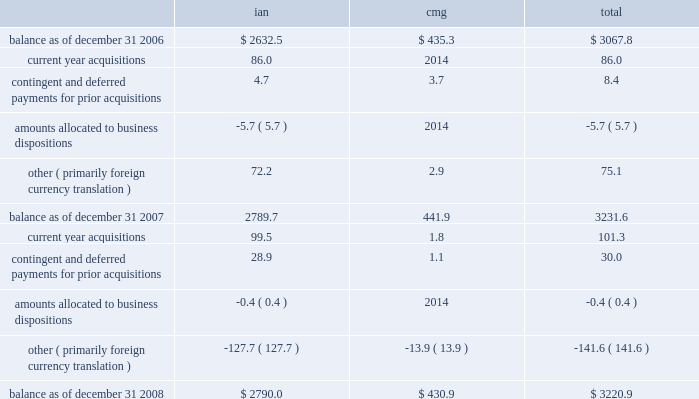Notes to consolidated financial statements 2014 ( continued ) ( amounts in millions , except per share amounts ) litigation settlement 2014 during may 2008 , the sec concluded its investigation that began in 2002 into our financial reporting practices , resulting in a settlement charge of $ 12.0 .
Investment impairments 2014 in 2007 we realized an other-than-temporary charge of $ 5.8 relating to a $ 12.5 investment in auction rate securities , representing our total investment in auction rate securities .
For additional information see note 15 .
Note 6 : intangible assets goodwill goodwill is the excess purchase price remaining from an acquisition after an allocation of purchase price has been made to identifiable assets acquired and liabilities assumed based on estimated fair values .
The changes in the carrying value of goodwill by segment for the years ended december 31 , 2008 and 2007 are as follows: .
During the latter part of the fourth quarter of 2008 our stock price declined significantly after our annual impairment review as of october 1 , 2008 , and our market capitalization was less than our book value as of december 31 , 2008 .
We considered whether there were any events or circumstances indicative of a triggering event and determined that the decline in stock price during the fourth quarter was an event that would 201cmore likely than not 201d reduce the fair value of our individual reporting units below their book value , requiring us to perform an interim impairment test for goodwill at the reporting unit level .
Based on the interim impairment test conducted , we concluded that there was no impairment of our goodwill as of december 31 , 2008 .
We will continue to monitor our stock price as it relates to the reconciliation of our market capitalization and the fair values of our individual reporting units throughout 2009 .
During our annual impairment reviews as of october 1 , 2006 our discounted future operating cash flow projections at one of our domestic advertising reporting units indicated that the implied fair value of the goodwill at this reporting unit was less than its book value , primarily due to client losses , resulting in a goodwill impairment charge of $ 27.2 in 2006 in our ian segment .
Other intangible assets included in other intangible assets are assets with indefinite lives not subject to amortization and assets with definite lives subject to amortization .
Other intangible assets include non-compete agreements , license costs , trade names and customer lists .
Intangible assets with definitive lives subject to amortization are amortized on a .
What was the percentage change in total goodwill carrying value from 2007 to 2008? 
Computations: ((3220.9 - 3231.6) / 3231.6)
Answer: -0.00331. 